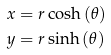Convert formula to latex. <formula><loc_0><loc_0><loc_500><loc_500>x & = r \cosh \, ( \theta ) \\ y & = r \sinh \, ( \theta )</formula> 